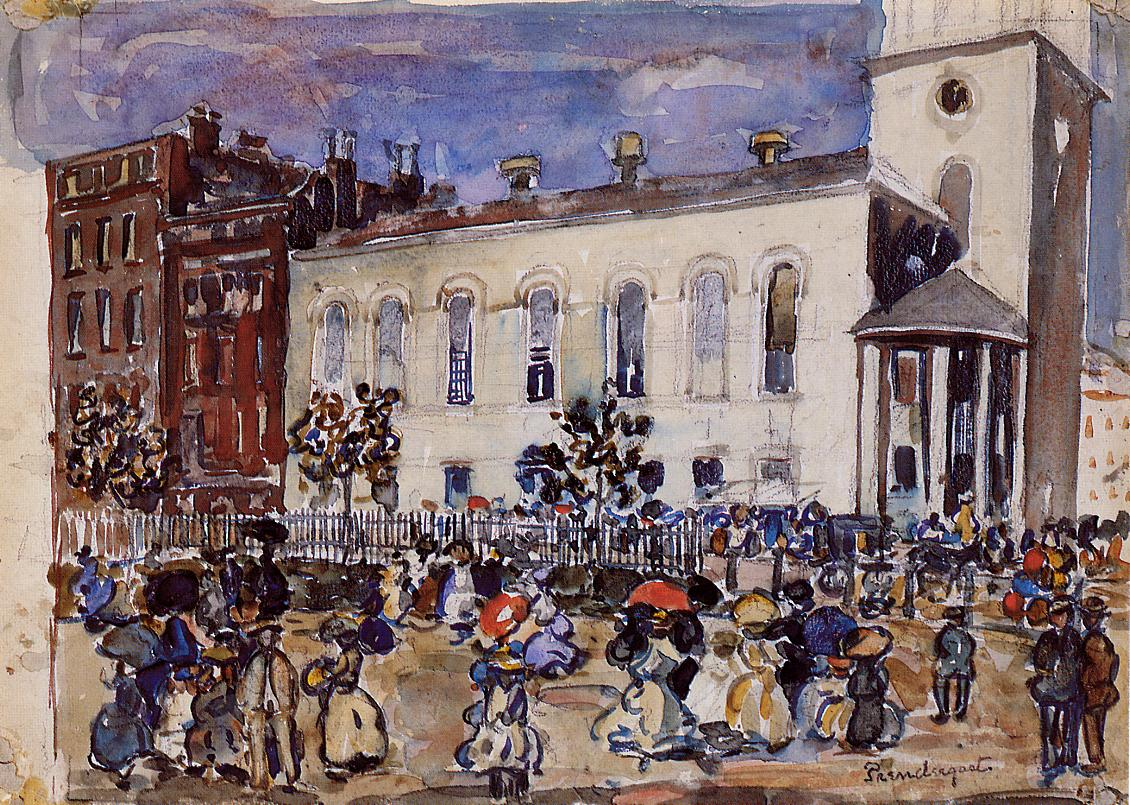What techniques did the artist use to convey movement in this painting? The artist employed the impressionist technique of quick, expressive brushstrokes that blur lines and shapes, which conveys a sense of motion and vivacity. This approach is particularly evident in the depictions of people and their activities, where the strokes are lighter and more fluid, suggesting their movement and the bustling energy of the street scene. 